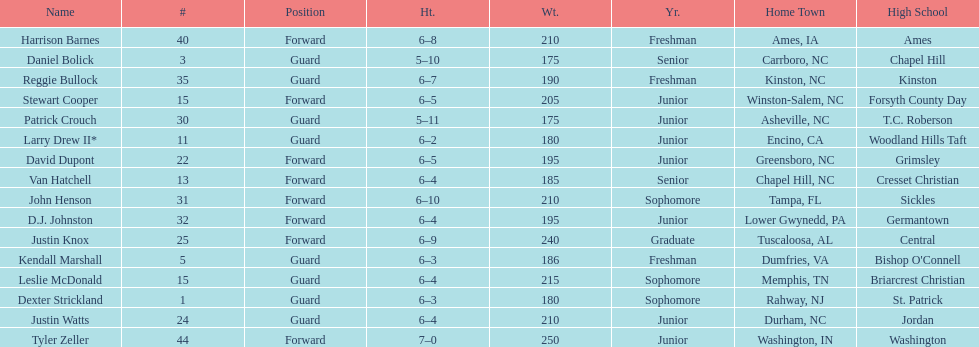How many players play a position other than guard? 8. 